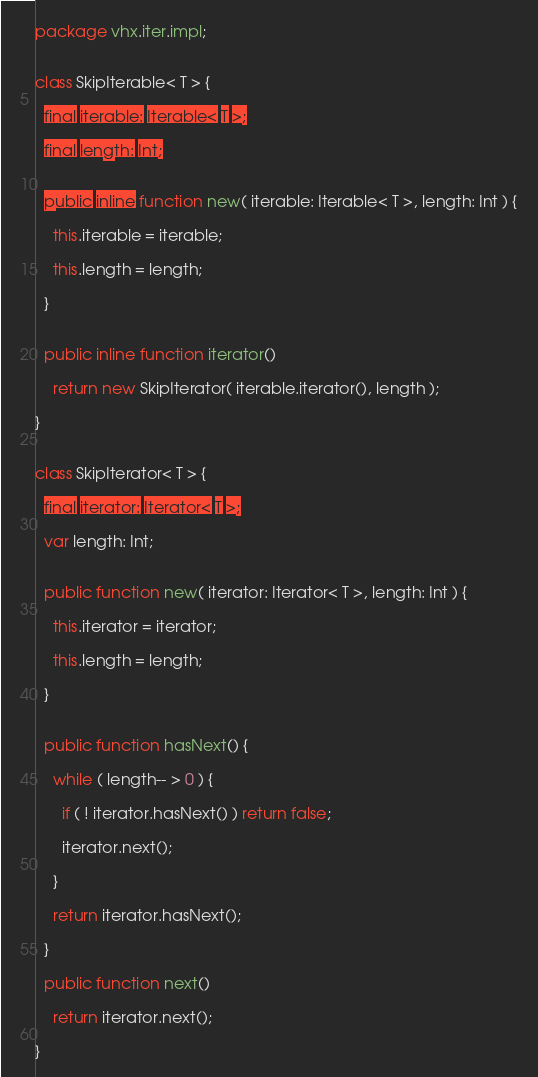<code> <loc_0><loc_0><loc_500><loc_500><_Haxe_>package vhx.iter.impl;


class SkipIterable< T > {

  final iterable: Iterable< T >;

  final length: Int;


  public inline function new( iterable: Iterable< T >, length: Int ) {

    this.iterable = iterable;

    this.length = length;

  }


  public inline function iterator()

    return new SkipIterator( iterable.iterator(), length );

}


class SkipIterator< T > {

  final iterator: Iterator< T >;

  var length: Int;


  public function new( iterator: Iterator< T >, length: Int ) {

    this.iterator = iterator;

    this.length = length;

  }


  public function hasNext() {

    while ( length-- > 0 ) {

      if ( ! iterator.hasNext() ) return false;

      iterator.next();

    }

    return iterator.hasNext();

  }

  public function next()

    return iterator.next();

}
</code> 